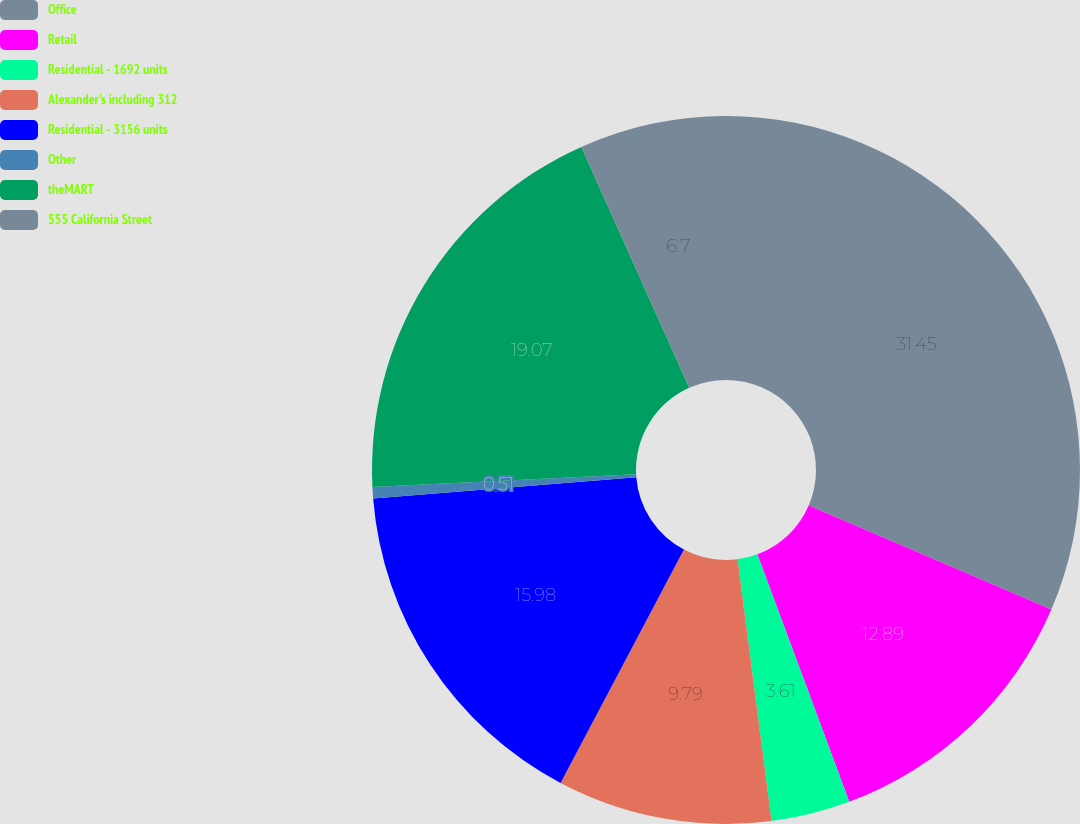<chart> <loc_0><loc_0><loc_500><loc_500><pie_chart><fcel>Office<fcel>Retail<fcel>Residential - 1692 units<fcel>Alexander's including 312<fcel>Residential - 3156 units<fcel>Other<fcel>theMART<fcel>555 California Street<nl><fcel>31.45%<fcel>12.89%<fcel>3.61%<fcel>9.79%<fcel>15.98%<fcel>0.51%<fcel>19.07%<fcel>6.7%<nl></chart> 